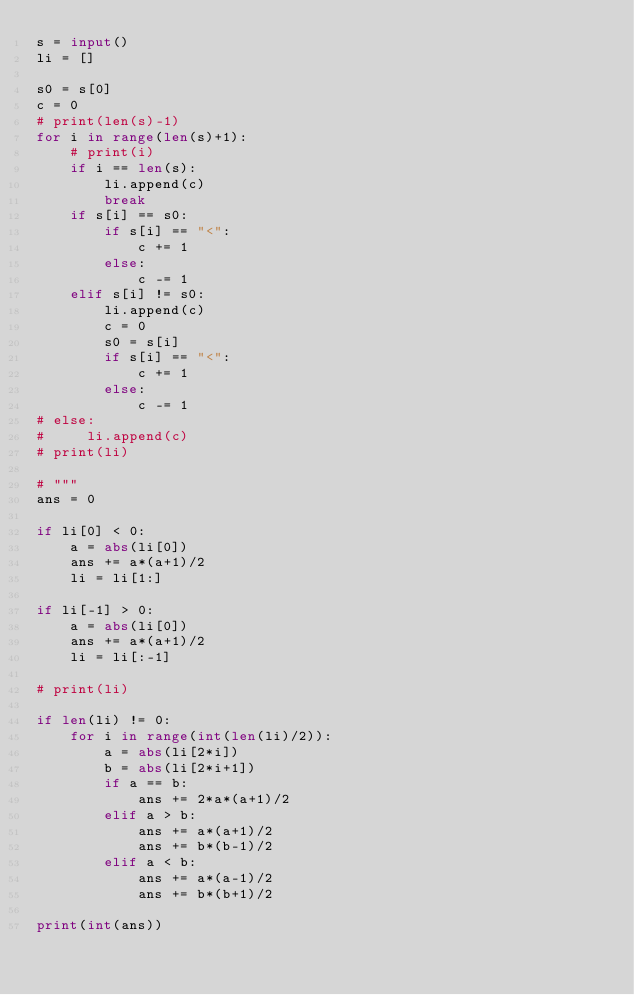<code> <loc_0><loc_0><loc_500><loc_500><_Python_>s = input()
li = []

s0 = s[0]
c = 0
# print(len(s)-1)
for i in range(len(s)+1):
    # print(i)
    if i == len(s):
        li.append(c)
        break
    if s[i] == s0:
        if s[i] == "<":
            c += 1
        else:
            c -= 1
    elif s[i] != s0:
        li.append(c)
        c = 0
        s0 = s[i]
        if s[i] == "<":
            c += 1
        else:
            c -= 1
# else:
#     li.append(c)
# print(li)

# """
ans = 0

if li[0] < 0:
    a = abs(li[0])
    ans += a*(a+1)/2
    li = li[1:]

if li[-1] > 0:
    a = abs(li[0])
    ans += a*(a+1)/2
    li = li[:-1]

# print(li)

if len(li) != 0:
    for i in range(int(len(li)/2)):
        a = abs(li[2*i])
        b = abs(li[2*i+1])
        if a == b:
            ans += 2*a*(a+1)/2
        elif a > b:
            ans += a*(a+1)/2
            ans += b*(b-1)/2
        elif a < b:
            ans += a*(a-1)/2
            ans += b*(b+1)/2

print(int(ans))
</code> 